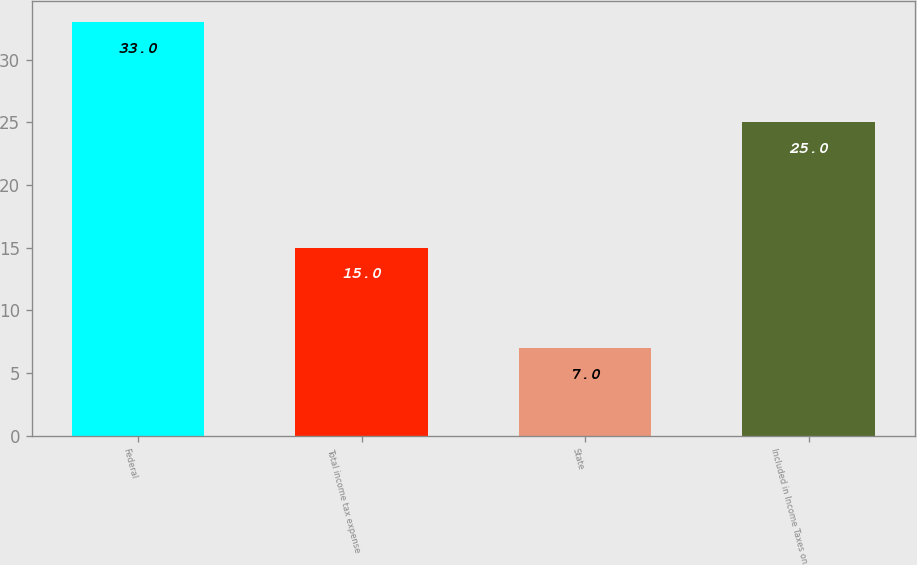Convert chart. <chart><loc_0><loc_0><loc_500><loc_500><bar_chart><fcel>Federal<fcel>Total income tax expense<fcel>State<fcel>Included in Income Taxes on<nl><fcel>33<fcel>15<fcel>7<fcel>25<nl></chart> 